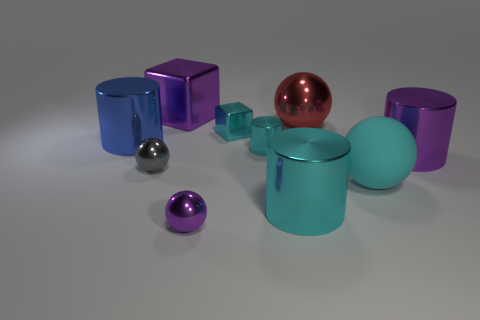Subtract 1 cylinders. How many cylinders are left? 3 Subtract all cubes. How many objects are left? 8 Subtract all small metallic things. Subtract all cyan balls. How many objects are left? 5 Add 5 tiny gray balls. How many tiny gray balls are left? 6 Add 4 big blocks. How many big blocks exist? 5 Subtract 0 gray cubes. How many objects are left? 10 